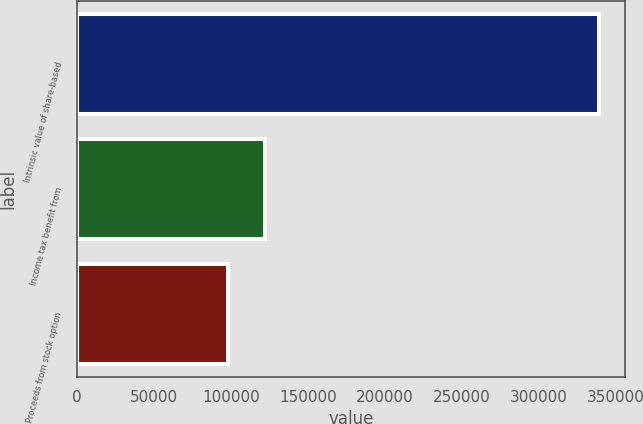Convert chart to OTSL. <chart><loc_0><loc_0><loc_500><loc_500><bar_chart><fcel>Intrinsic value of share-based<fcel>Income tax benefit from<fcel>Proceeds from stock option<nl><fcel>339154<fcel>121928<fcel>97792<nl></chart> 